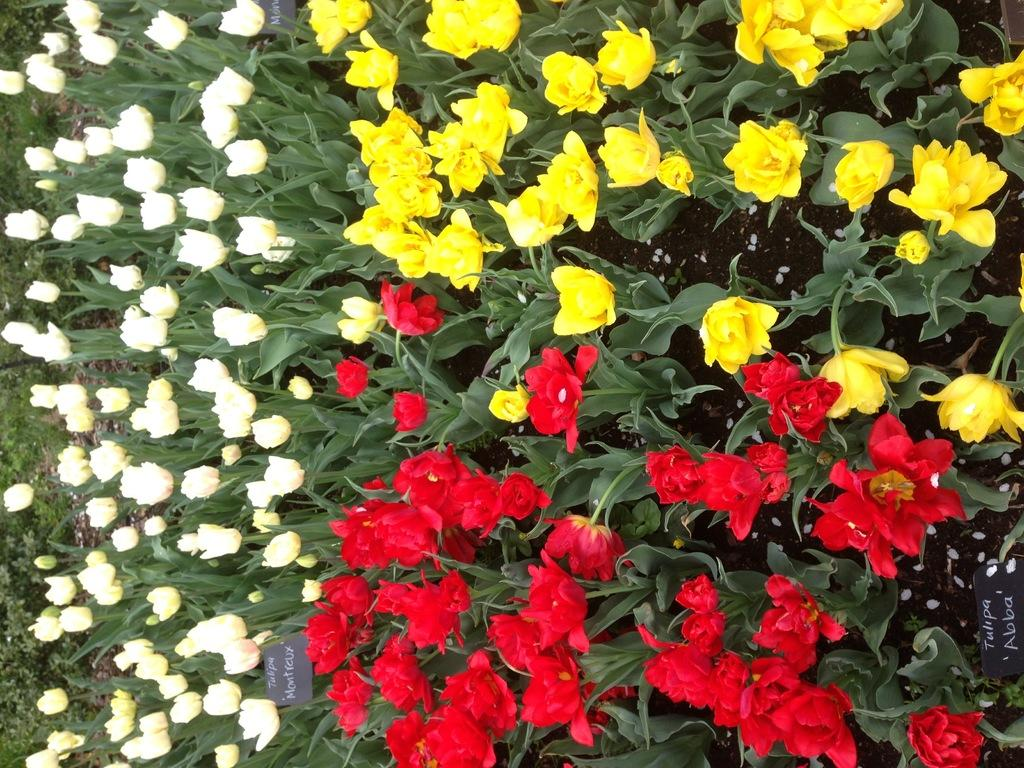What type of plants can be seen in the image? There are flower plants in the image. What colors are the flowers on the plants? The flowers have white, yellow, and red colors. Are there any additional features associated with the plants in the image? Yes, there are small name boards in the image. How does the yoke fit into the image? There is no yoke present in the image, so it cannot be incorporated or fit into the scene. 